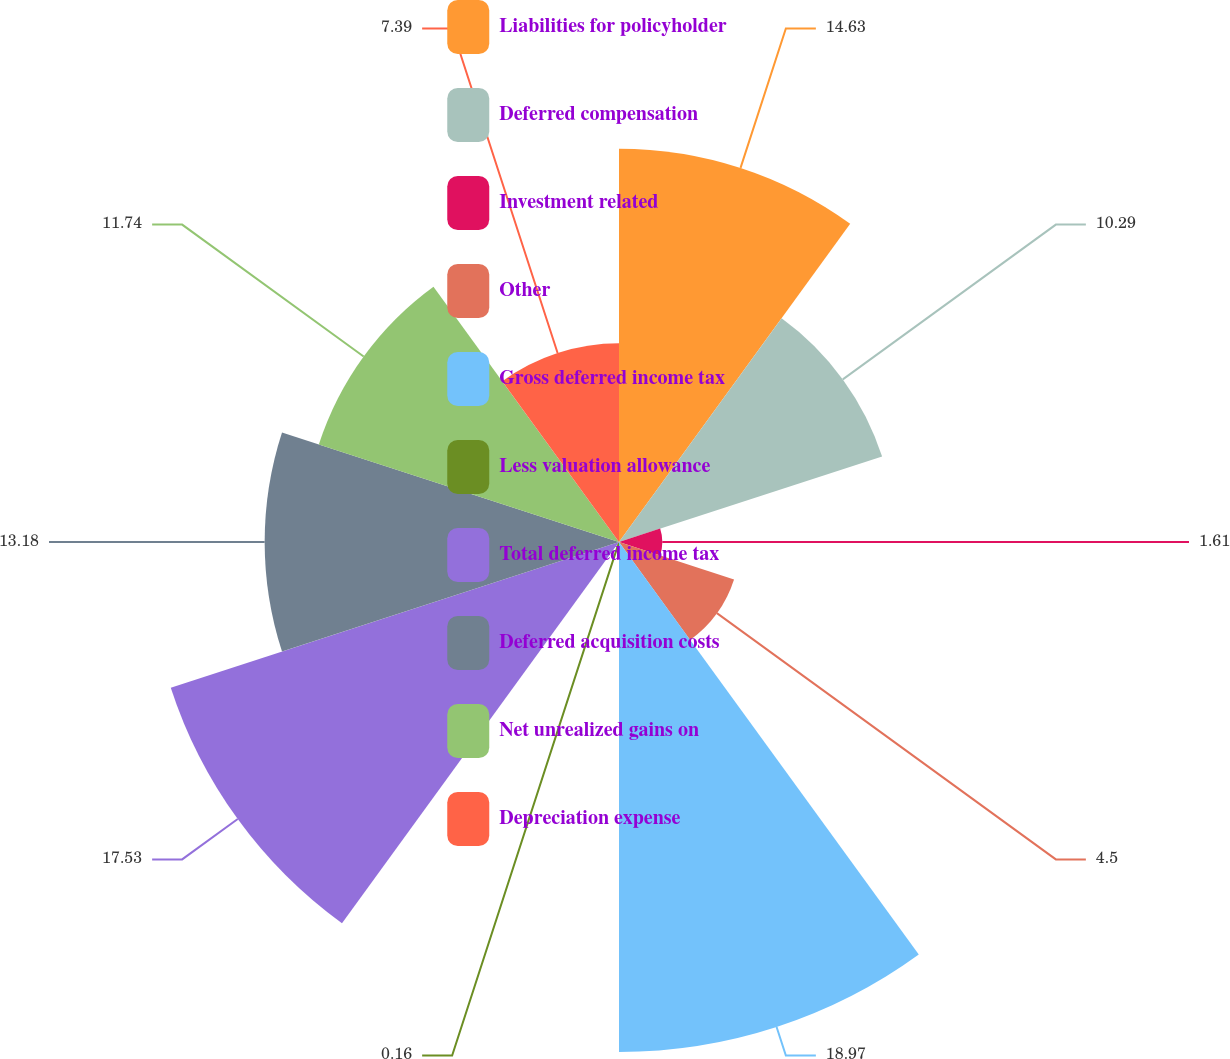<chart> <loc_0><loc_0><loc_500><loc_500><pie_chart><fcel>Liabilities for policyholder<fcel>Deferred compensation<fcel>Investment related<fcel>Other<fcel>Gross deferred income tax<fcel>Less valuation allowance<fcel>Total deferred income tax<fcel>Deferred acquisition costs<fcel>Net unrealized gains on<fcel>Depreciation expense<nl><fcel>14.63%<fcel>10.29%<fcel>1.61%<fcel>4.5%<fcel>18.97%<fcel>0.16%<fcel>17.53%<fcel>13.18%<fcel>11.74%<fcel>7.39%<nl></chart> 